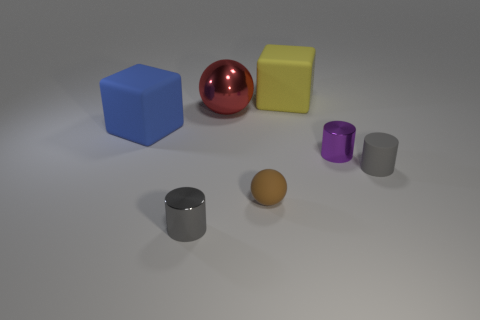What is the big yellow object made of?
Your answer should be very brief. Rubber. What color is the metal thing that is in front of the red sphere and to the left of the matte ball?
Offer a terse response. Gray. Are there an equal number of big matte blocks to the left of the big red shiny thing and large objects to the right of the small brown sphere?
Provide a succinct answer. Yes. The other block that is made of the same material as the yellow cube is what color?
Keep it short and to the point. Blue. There is a small matte cylinder; is it the same color as the big matte cube left of the big red shiny sphere?
Your answer should be compact. No. Are there any spheres that are behind the rubber cube right of the tiny shiny thing that is in front of the gray rubber cylinder?
Provide a succinct answer. No. What is the shape of the other small object that is made of the same material as the brown thing?
Keep it short and to the point. Cylinder. Are there any other things that are the same shape as the brown rubber object?
Give a very brief answer. Yes. What is the shape of the large blue rubber object?
Your answer should be compact. Cube. Does the gray object that is left of the small purple cylinder have the same shape as the big yellow thing?
Provide a short and direct response. No. 